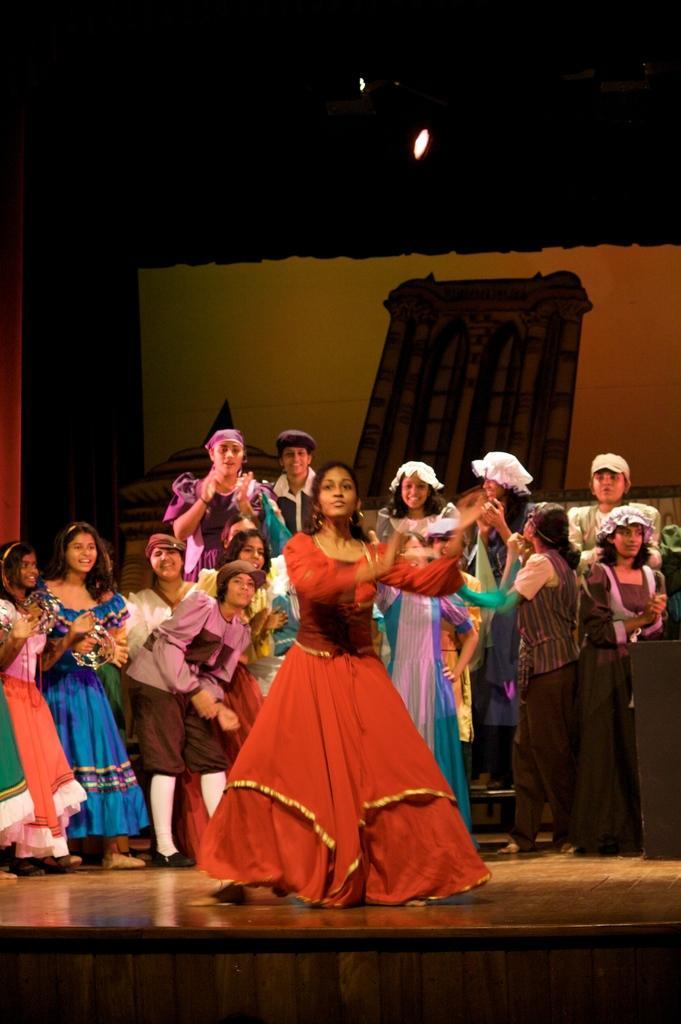Could you give a brief overview of what you see in this image? There is a girl in the foreground area of the image, it seems like dancing, there are people standing behind her. There is an object and a spotlight in the background. 